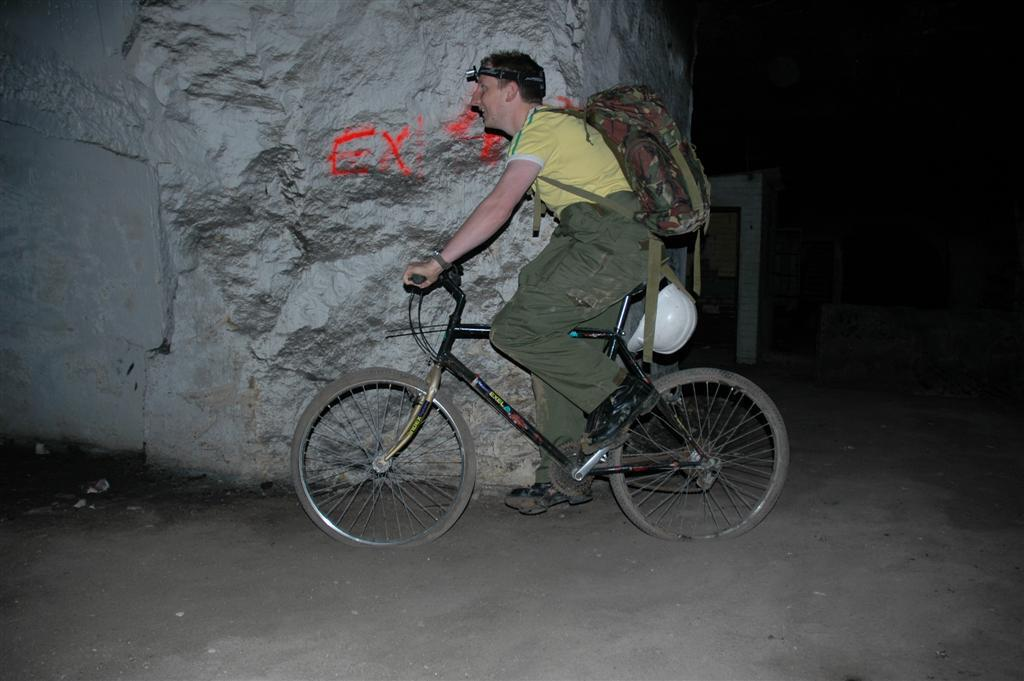What is the person in the image doing? There is a person riding a bicycle in the image. What is the person wearing on their body? The person is wearing a bag and spectacles. What can be seen in the background of the image? There are stones visible in the background. What type of jar can be seen on the edge of the bicycle in the image? There is no jar present on the edge of the bicycle in the image. 